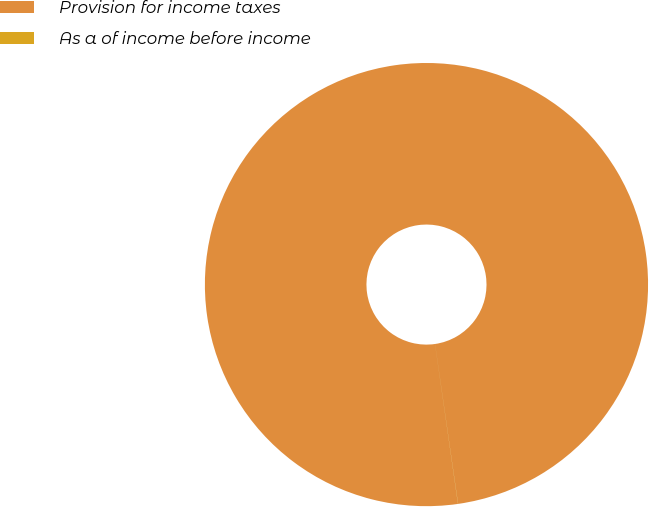Convert chart to OTSL. <chart><loc_0><loc_0><loc_500><loc_500><pie_chart><fcel>Provision for income taxes<fcel>As a of income before income<nl><fcel>99.99%<fcel>0.01%<nl></chart> 